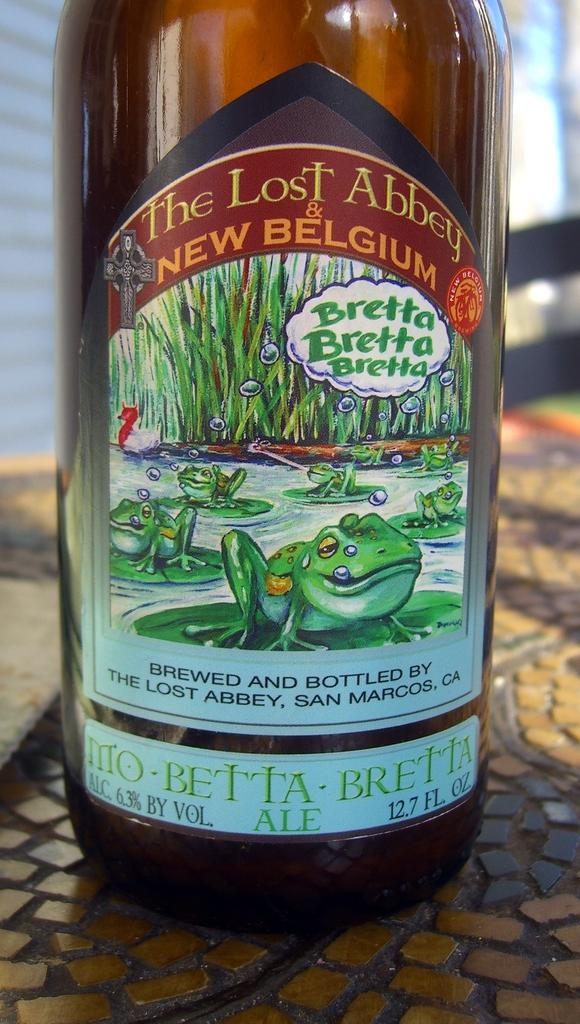<image>
Provide a brief description of the given image. Beer bottle with a label that says "New Belgium" on it. 